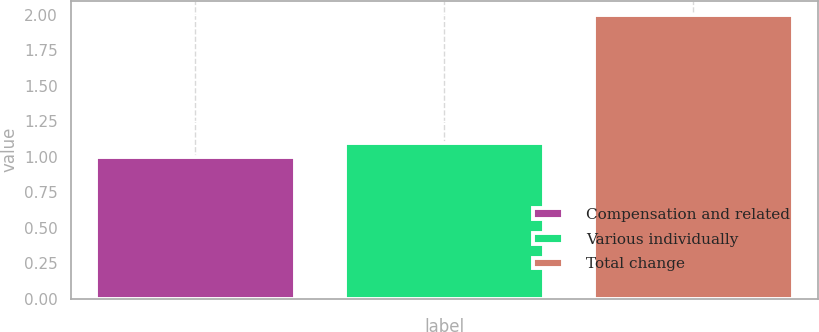<chart> <loc_0><loc_0><loc_500><loc_500><bar_chart><fcel>Compensation and related<fcel>Various individually<fcel>Total change<nl><fcel>1<fcel>1.1<fcel>2<nl></chart> 